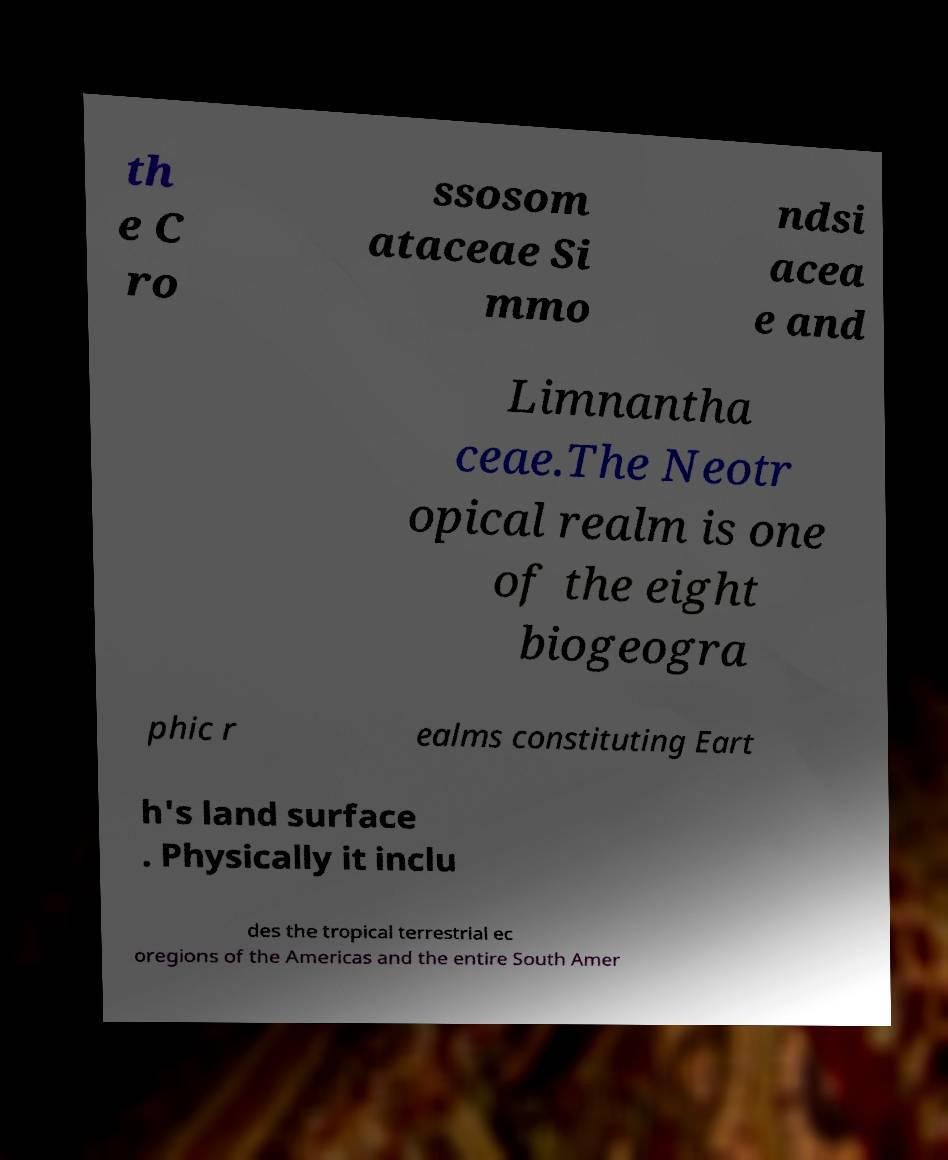Can you accurately transcribe the text from the provided image for me? th e C ro ssosom ataceae Si mmo ndsi acea e and Limnantha ceae.The Neotr opical realm is one of the eight biogeogra phic r ealms constituting Eart h's land surface . Physically it inclu des the tropical terrestrial ec oregions of the Americas and the entire South Amer 